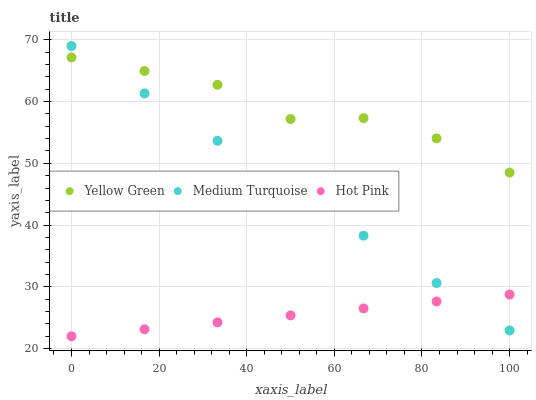Does Hot Pink have the minimum area under the curve?
Answer yes or no. Yes. Does Yellow Green have the maximum area under the curve?
Answer yes or no. Yes. Does Medium Turquoise have the minimum area under the curve?
Answer yes or no. No. Does Medium Turquoise have the maximum area under the curve?
Answer yes or no. No. Is Hot Pink the smoothest?
Answer yes or no. Yes. Is Yellow Green the roughest?
Answer yes or no. Yes. Is Medium Turquoise the smoothest?
Answer yes or no. No. Is Medium Turquoise the roughest?
Answer yes or no. No. Does Hot Pink have the lowest value?
Answer yes or no. Yes. Does Medium Turquoise have the lowest value?
Answer yes or no. No. Does Medium Turquoise have the highest value?
Answer yes or no. Yes. Does Yellow Green have the highest value?
Answer yes or no. No. Is Hot Pink less than Yellow Green?
Answer yes or no. Yes. Is Yellow Green greater than Hot Pink?
Answer yes or no. Yes. Does Medium Turquoise intersect Yellow Green?
Answer yes or no. Yes. Is Medium Turquoise less than Yellow Green?
Answer yes or no. No. Is Medium Turquoise greater than Yellow Green?
Answer yes or no. No. Does Hot Pink intersect Yellow Green?
Answer yes or no. No. 